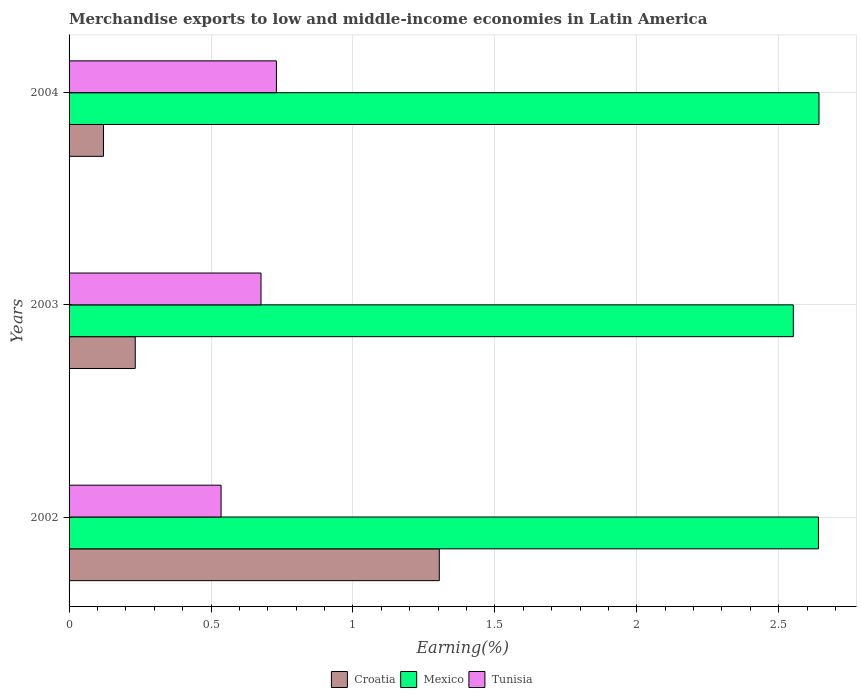Are the number of bars per tick equal to the number of legend labels?
Provide a succinct answer. Yes. How many bars are there on the 3rd tick from the top?
Offer a very short reply. 3. What is the label of the 3rd group of bars from the top?
Offer a very short reply. 2002. What is the percentage of amount earned from merchandise exports in Mexico in 2004?
Offer a terse response. 2.64. Across all years, what is the maximum percentage of amount earned from merchandise exports in Mexico?
Give a very brief answer. 2.64. Across all years, what is the minimum percentage of amount earned from merchandise exports in Croatia?
Offer a terse response. 0.12. In which year was the percentage of amount earned from merchandise exports in Croatia maximum?
Provide a succinct answer. 2002. What is the total percentage of amount earned from merchandise exports in Tunisia in the graph?
Keep it short and to the point. 1.94. What is the difference between the percentage of amount earned from merchandise exports in Tunisia in 2003 and that in 2004?
Give a very brief answer. -0.05. What is the difference between the percentage of amount earned from merchandise exports in Mexico in 2004 and the percentage of amount earned from merchandise exports in Tunisia in 2003?
Provide a succinct answer. 1.97. What is the average percentage of amount earned from merchandise exports in Mexico per year?
Offer a terse response. 2.61. In the year 2003, what is the difference between the percentage of amount earned from merchandise exports in Croatia and percentage of amount earned from merchandise exports in Tunisia?
Your answer should be very brief. -0.44. What is the ratio of the percentage of amount earned from merchandise exports in Tunisia in 2003 to that in 2004?
Provide a succinct answer. 0.93. What is the difference between the highest and the second highest percentage of amount earned from merchandise exports in Croatia?
Your answer should be compact. 1.07. What is the difference between the highest and the lowest percentage of amount earned from merchandise exports in Croatia?
Keep it short and to the point. 1.18. Is the sum of the percentage of amount earned from merchandise exports in Mexico in 2003 and 2004 greater than the maximum percentage of amount earned from merchandise exports in Croatia across all years?
Your response must be concise. Yes. What does the 2nd bar from the top in 2003 represents?
Provide a succinct answer. Mexico. What does the 3rd bar from the bottom in 2003 represents?
Give a very brief answer. Tunisia. Is it the case that in every year, the sum of the percentage of amount earned from merchandise exports in Croatia and percentage of amount earned from merchandise exports in Tunisia is greater than the percentage of amount earned from merchandise exports in Mexico?
Your answer should be very brief. No. How many years are there in the graph?
Provide a succinct answer. 3. Are the values on the major ticks of X-axis written in scientific E-notation?
Offer a terse response. No. Does the graph contain any zero values?
Offer a terse response. No. Where does the legend appear in the graph?
Offer a very short reply. Bottom center. How are the legend labels stacked?
Provide a short and direct response. Horizontal. What is the title of the graph?
Offer a terse response. Merchandise exports to low and middle-income economies in Latin America. What is the label or title of the X-axis?
Provide a short and direct response. Earning(%). What is the label or title of the Y-axis?
Give a very brief answer. Years. What is the Earning(%) in Croatia in 2002?
Keep it short and to the point. 1.3. What is the Earning(%) in Mexico in 2002?
Make the answer very short. 2.64. What is the Earning(%) in Tunisia in 2002?
Provide a short and direct response. 0.54. What is the Earning(%) of Croatia in 2003?
Offer a terse response. 0.23. What is the Earning(%) of Mexico in 2003?
Your response must be concise. 2.55. What is the Earning(%) in Tunisia in 2003?
Ensure brevity in your answer.  0.68. What is the Earning(%) in Croatia in 2004?
Provide a succinct answer. 0.12. What is the Earning(%) in Mexico in 2004?
Make the answer very short. 2.64. What is the Earning(%) in Tunisia in 2004?
Give a very brief answer. 0.73. Across all years, what is the maximum Earning(%) in Croatia?
Offer a terse response. 1.3. Across all years, what is the maximum Earning(%) in Mexico?
Ensure brevity in your answer.  2.64. Across all years, what is the maximum Earning(%) of Tunisia?
Your answer should be very brief. 0.73. Across all years, what is the minimum Earning(%) in Croatia?
Provide a short and direct response. 0.12. Across all years, what is the minimum Earning(%) of Mexico?
Offer a terse response. 2.55. Across all years, what is the minimum Earning(%) in Tunisia?
Offer a terse response. 0.54. What is the total Earning(%) in Croatia in the graph?
Ensure brevity in your answer.  1.66. What is the total Earning(%) in Mexico in the graph?
Make the answer very short. 7.83. What is the total Earning(%) in Tunisia in the graph?
Provide a succinct answer. 1.94. What is the difference between the Earning(%) in Croatia in 2002 and that in 2003?
Ensure brevity in your answer.  1.07. What is the difference between the Earning(%) in Mexico in 2002 and that in 2003?
Keep it short and to the point. 0.09. What is the difference between the Earning(%) of Tunisia in 2002 and that in 2003?
Offer a very short reply. -0.14. What is the difference between the Earning(%) in Croatia in 2002 and that in 2004?
Provide a succinct answer. 1.18. What is the difference between the Earning(%) in Mexico in 2002 and that in 2004?
Your response must be concise. -0. What is the difference between the Earning(%) in Tunisia in 2002 and that in 2004?
Your answer should be very brief. -0.2. What is the difference between the Earning(%) of Croatia in 2003 and that in 2004?
Ensure brevity in your answer.  0.11. What is the difference between the Earning(%) of Mexico in 2003 and that in 2004?
Provide a short and direct response. -0.09. What is the difference between the Earning(%) in Tunisia in 2003 and that in 2004?
Give a very brief answer. -0.05. What is the difference between the Earning(%) of Croatia in 2002 and the Earning(%) of Mexico in 2003?
Provide a short and direct response. -1.25. What is the difference between the Earning(%) of Croatia in 2002 and the Earning(%) of Tunisia in 2003?
Give a very brief answer. 0.63. What is the difference between the Earning(%) in Mexico in 2002 and the Earning(%) in Tunisia in 2003?
Provide a short and direct response. 1.96. What is the difference between the Earning(%) in Croatia in 2002 and the Earning(%) in Mexico in 2004?
Your answer should be compact. -1.34. What is the difference between the Earning(%) in Croatia in 2002 and the Earning(%) in Tunisia in 2004?
Make the answer very short. 0.57. What is the difference between the Earning(%) of Mexico in 2002 and the Earning(%) of Tunisia in 2004?
Offer a very short reply. 1.91. What is the difference between the Earning(%) of Croatia in 2003 and the Earning(%) of Mexico in 2004?
Your answer should be compact. -2.41. What is the difference between the Earning(%) in Croatia in 2003 and the Earning(%) in Tunisia in 2004?
Give a very brief answer. -0.5. What is the difference between the Earning(%) in Mexico in 2003 and the Earning(%) in Tunisia in 2004?
Make the answer very short. 1.82. What is the average Earning(%) in Croatia per year?
Your response must be concise. 0.55. What is the average Earning(%) of Mexico per year?
Your response must be concise. 2.61. What is the average Earning(%) of Tunisia per year?
Keep it short and to the point. 0.65. In the year 2002, what is the difference between the Earning(%) of Croatia and Earning(%) of Mexico?
Your answer should be very brief. -1.34. In the year 2002, what is the difference between the Earning(%) in Croatia and Earning(%) in Tunisia?
Offer a terse response. 0.77. In the year 2002, what is the difference between the Earning(%) of Mexico and Earning(%) of Tunisia?
Offer a terse response. 2.1. In the year 2003, what is the difference between the Earning(%) in Croatia and Earning(%) in Mexico?
Your answer should be compact. -2.32. In the year 2003, what is the difference between the Earning(%) of Croatia and Earning(%) of Tunisia?
Give a very brief answer. -0.44. In the year 2003, what is the difference between the Earning(%) in Mexico and Earning(%) in Tunisia?
Give a very brief answer. 1.88. In the year 2004, what is the difference between the Earning(%) of Croatia and Earning(%) of Mexico?
Ensure brevity in your answer.  -2.52. In the year 2004, what is the difference between the Earning(%) of Croatia and Earning(%) of Tunisia?
Provide a short and direct response. -0.61. In the year 2004, what is the difference between the Earning(%) of Mexico and Earning(%) of Tunisia?
Offer a terse response. 1.91. What is the ratio of the Earning(%) of Croatia in 2002 to that in 2003?
Your answer should be very brief. 5.59. What is the ratio of the Earning(%) of Mexico in 2002 to that in 2003?
Keep it short and to the point. 1.03. What is the ratio of the Earning(%) in Tunisia in 2002 to that in 2003?
Make the answer very short. 0.79. What is the ratio of the Earning(%) in Croatia in 2002 to that in 2004?
Provide a short and direct response. 10.76. What is the ratio of the Earning(%) in Mexico in 2002 to that in 2004?
Your response must be concise. 1. What is the ratio of the Earning(%) of Tunisia in 2002 to that in 2004?
Make the answer very short. 0.73. What is the ratio of the Earning(%) of Croatia in 2003 to that in 2004?
Keep it short and to the point. 1.92. What is the ratio of the Earning(%) of Mexico in 2003 to that in 2004?
Ensure brevity in your answer.  0.97. What is the ratio of the Earning(%) of Tunisia in 2003 to that in 2004?
Ensure brevity in your answer.  0.93. What is the difference between the highest and the second highest Earning(%) of Croatia?
Your response must be concise. 1.07. What is the difference between the highest and the second highest Earning(%) of Mexico?
Provide a short and direct response. 0. What is the difference between the highest and the second highest Earning(%) in Tunisia?
Make the answer very short. 0.05. What is the difference between the highest and the lowest Earning(%) in Croatia?
Give a very brief answer. 1.18. What is the difference between the highest and the lowest Earning(%) of Mexico?
Keep it short and to the point. 0.09. What is the difference between the highest and the lowest Earning(%) in Tunisia?
Ensure brevity in your answer.  0.2. 